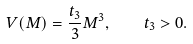<formula> <loc_0><loc_0><loc_500><loc_500>V ( M ) = \frac { t _ { 3 } } { 3 } M ^ { 3 } , \quad t _ { 3 } > 0 .</formula> 